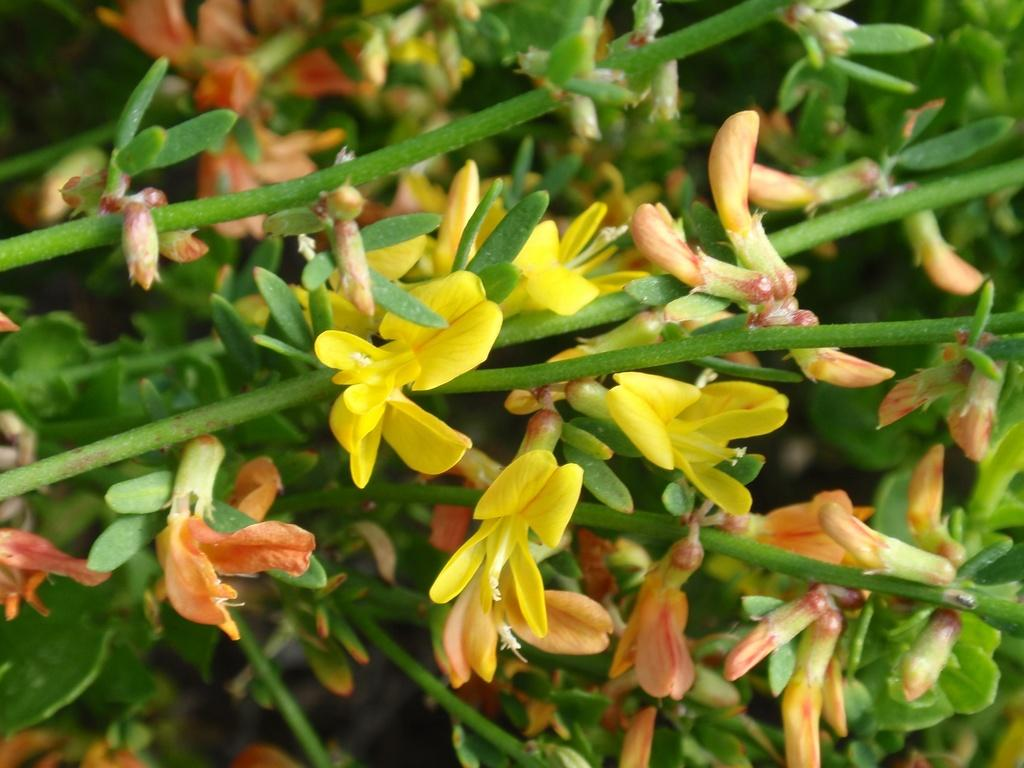What type of plants can be seen in the image? There are flowers in the image. What colors are the flowers? The flowers are in orange and yellow colors. What else can be seen in the image besides the flowers? There are leaves in the image. What color are the leaves? The leaves are green in color. What industry is depicted in the image? There is no industry present in the image; it features flowers and leaves. What attraction can be seen in the image? There is no attraction present in the image; it features flowers and leaves. 